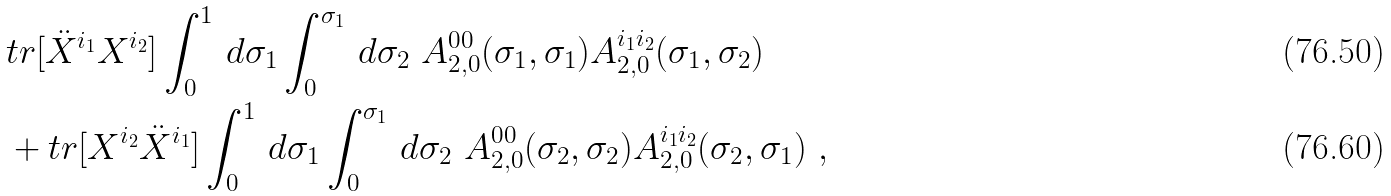<formula> <loc_0><loc_0><loc_500><loc_500>& t r [ \ddot { X } ^ { i _ { 1 } } X ^ { i _ { 2 } } ] \int _ { 0 } ^ { 1 } \, d \sigma _ { 1 } \int _ { 0 } ^ { \sigma _ { 1 } } \, d \sigma _ { 2 } \ A _ { 2 , 0 } ^ { 0 0 } ( \sigma _ { 1 } , \sigma _ { 1 } ) A _ { 2 , 0 } ^ { i _ { 1 } i _ { 2 } } ( \sigma _ { 1 } , \sigma _ { 2 } ) \\ & + t r [ X ^ { i _ { 2 } } \ddot { X } ^ { i _ { 1 } } ] \int _ { 0 } ^ { 1 } \, d \sigma _ { 1 } \int _ { 0 } ^ { \sigma _ { 1 } } \, d \sigma _ { 2 } \ A _ { 2 , 0 } ^ { 0 0 } ( \sigma _ { 2 } , \sigma _ { 2 } ) A _ { 2 , 0 } ^ { i _ { 1 } i _ { 2 } } ( \sigma _ { 2 } , \sigma _ { 1 } ) \ ,</formula> 